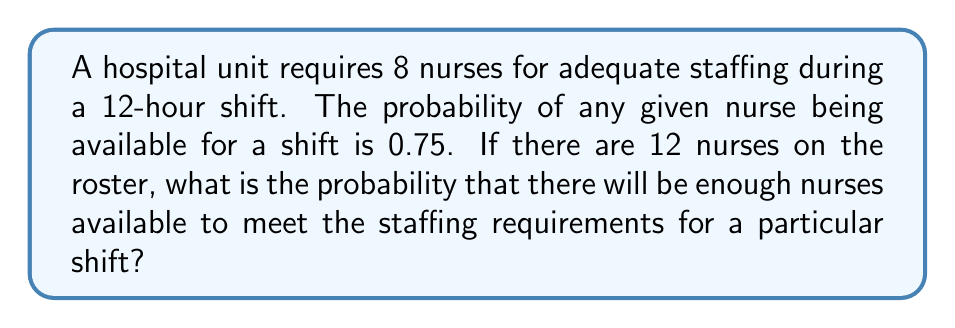Teach me how to tackle this problem. Let's approach this step-by-step:

1) This is a binomial probability problem. We need to find the probability of having at least 8 nurses available out of 12.

2) Let X be the number of nurses available. X follows a binomial distribution with n = 12 and p = 0.75.

3) We need to find P(X ≥ 8) = 1 - P(X < 8) = 1 - P(X ≤ 7)

4) The probability mass function for a binomial distribution is:

   $$P(X = k) = \binom{n}{k} p^k (1-p)^{n-k}$$

5) We need to sum this for k = 0 to 7:

   $$P(X \leq 7) = \sum_{k=0}^7 \binom{12}{k} (0.75)^k (0.25)^{12-k}$$

6) Calculating this sum:

   $$P(X \leq 7) = 0.0416$$

7) Therefore, P(X ≥ 8) = 1 - 0.0416 = 0.9584

So, the probability of having at least 8 nurses available is 0.9584 or about 95.84%.
Answer: 0.9584 